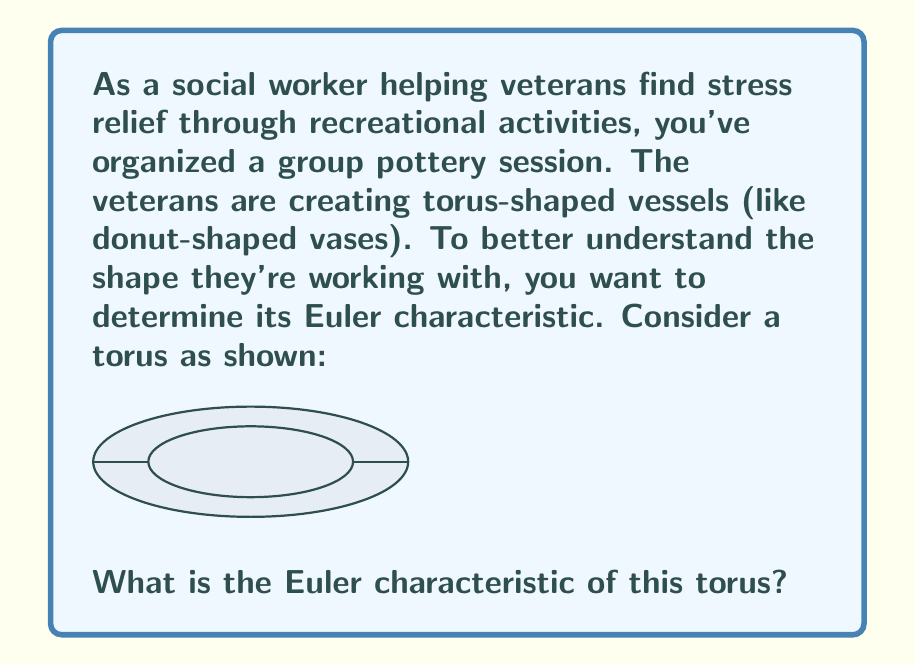Can you answer this question? To determine the Euler characteristic of a torus, we'll follow these steps:

1) Recall the formula for Euler characteristic:
   $$\chi = V - E + F$$
   where $V$ is the number of vertices, $E$ is the number of edges, and $F$ is the number of faces.

2) Visualize a simple triangulation of the torus:
   - Imagine the torus as a rectangle with opposite edges identified.
   - Divide this rectangle into a grid of squares.
   - Divide each square into two triangles.

3) Count the components:
   - Vertices: Let's say we use a 3x3 grid. This gives us 9 vertices, but due to edge identification, the corners are all the same point, and the edge midpoints are identified in pairs. So, $V = 1 + 3 + 5 = 9$.
   - Edges: We have 18 edges, but again due to identification, $E = 3 + 6 + 9 = 18$.
   - Faces: Each square is divided into 2 triangles, so $F = 2 * 9 = 18$.

4) Calculate the Euler characteristic:
   $$\chi = V - E + F = 9 - 18 + 18 = 0$$

5) Note: This result is independent of the specific triangulation we chose. Any valid triangulation of a torus will yield the same Euler characteristic.
Answer: $0$ 